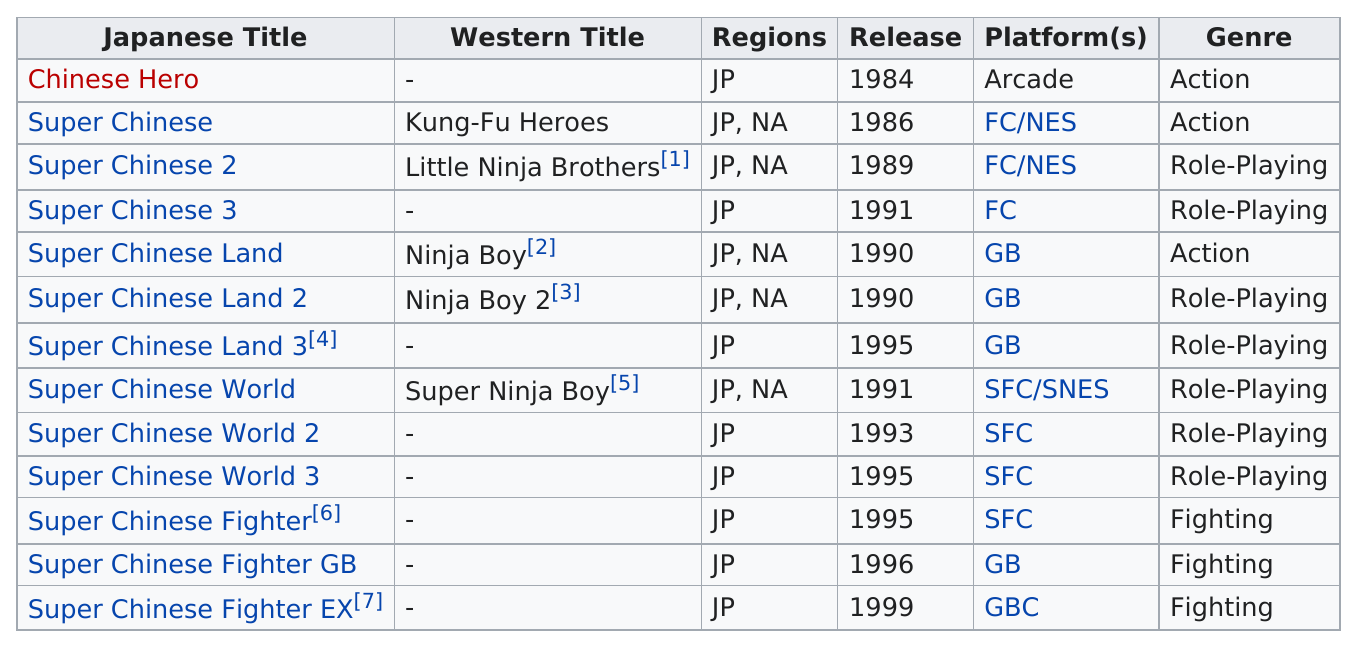Specify some key components in this picture. The platforms with the most titles released were GB. There have been a total of 13 Super Chinese games released. Approximately three unique music genres were released between the years 1989 and 1999. The first Chinese hero game was released before the release of Super Chinese Heroes, which is a game that has become widely popular among players. The last Super Chinese game was released in 1999. 